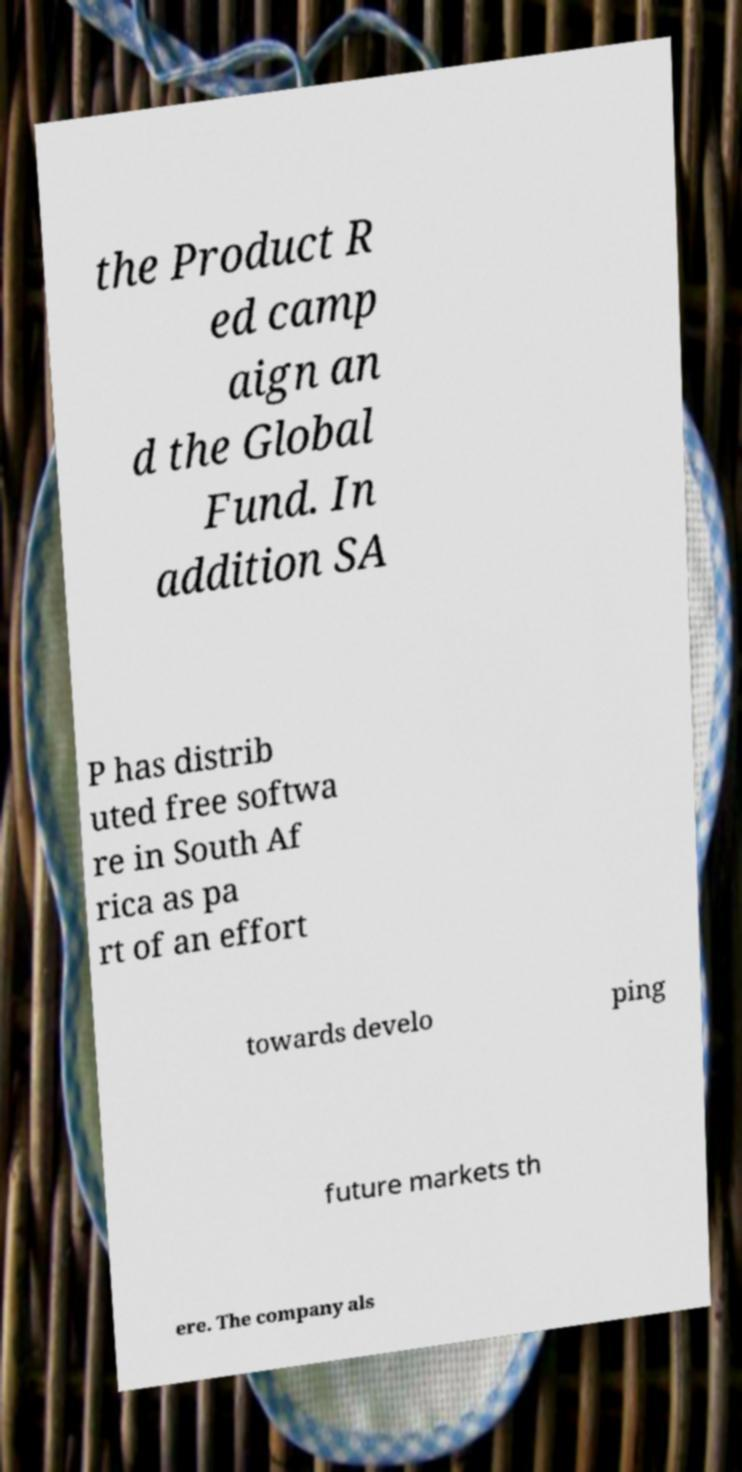There's text embedded in this image that I need extracted. Can you transcribe it verbatim? the Product R ed camp aign an d the Global Fund. In addition SA P has distrib uted free softwa re in South Af rica as pa rt of an effort towards develo ping future markets th ere. The company als 